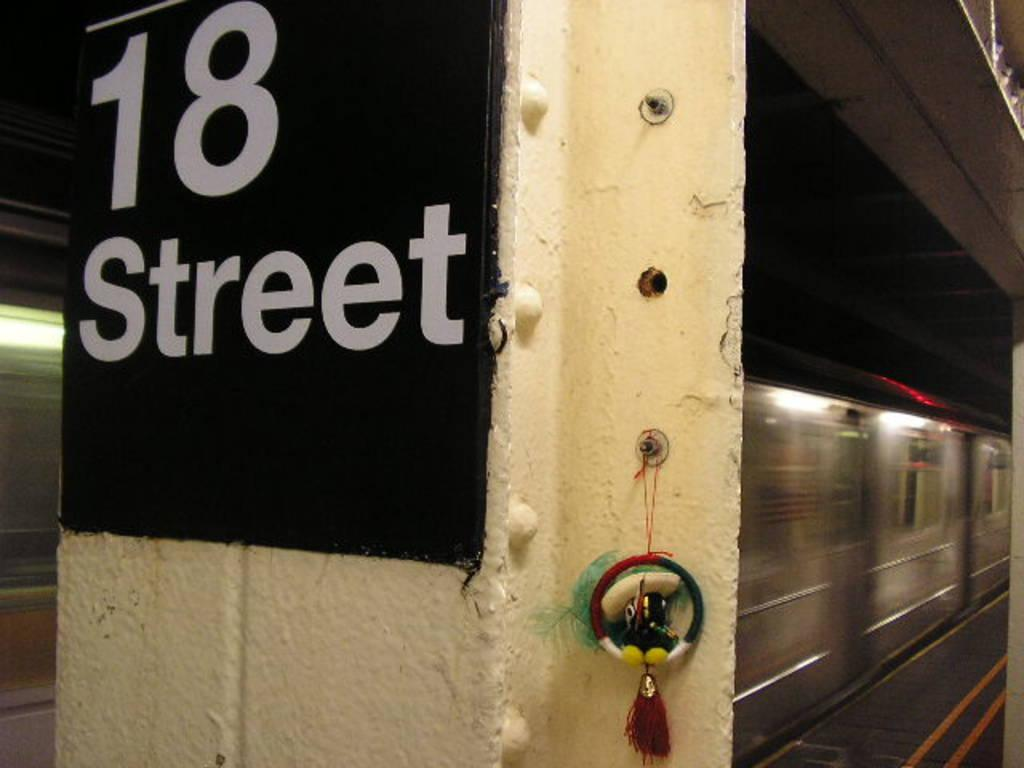What is the main object in the center of the image? There is a pillar with an object in the center of the image. What is written on the board in the center of the image? There is a board with text in the center of the image. What can be seen in the background of the image? There is a wall, a platform, a train, and lights in the background of the image. What type of blade is being used by the person in the image? There is no person or blade present in the image. What religious beliefs are represented in the image? There is no indication of any religious beliefs in the image. 